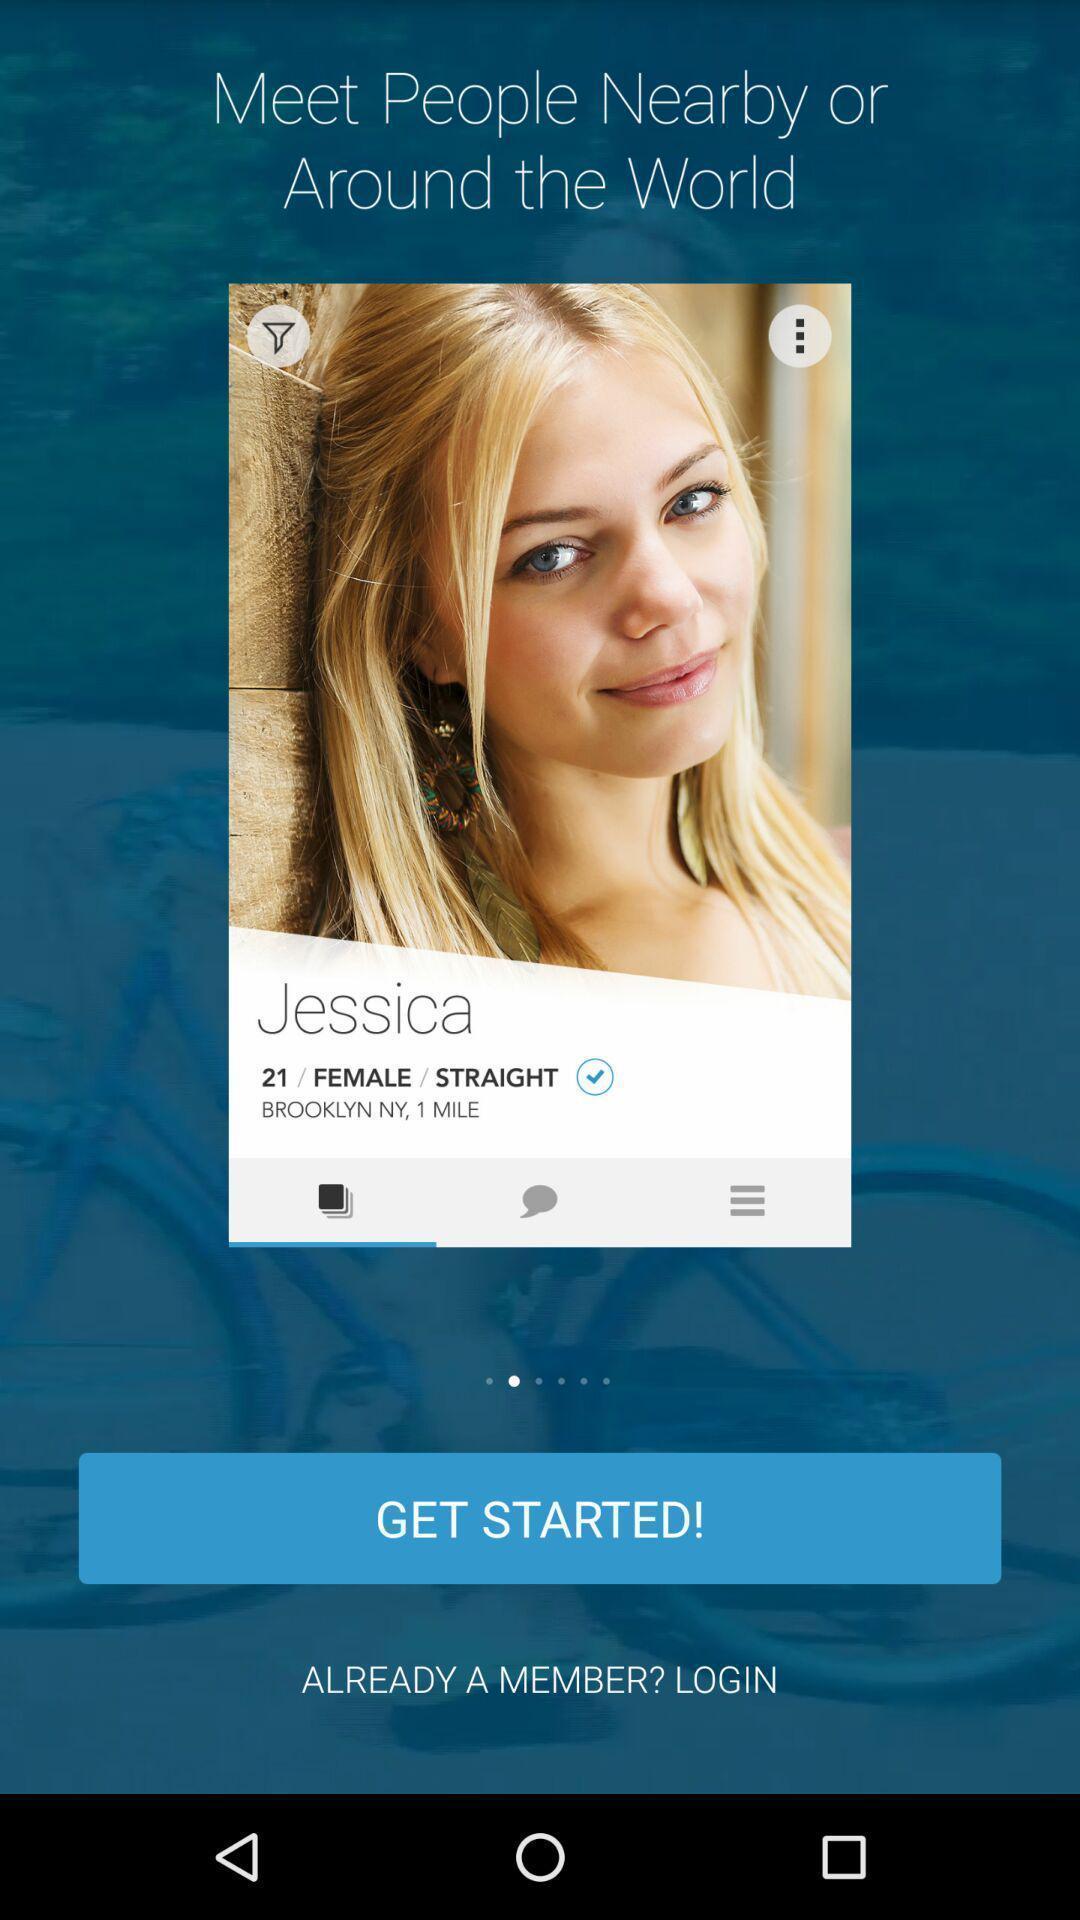Summarize the information in this screenshot. Welcome page of a dating app. 